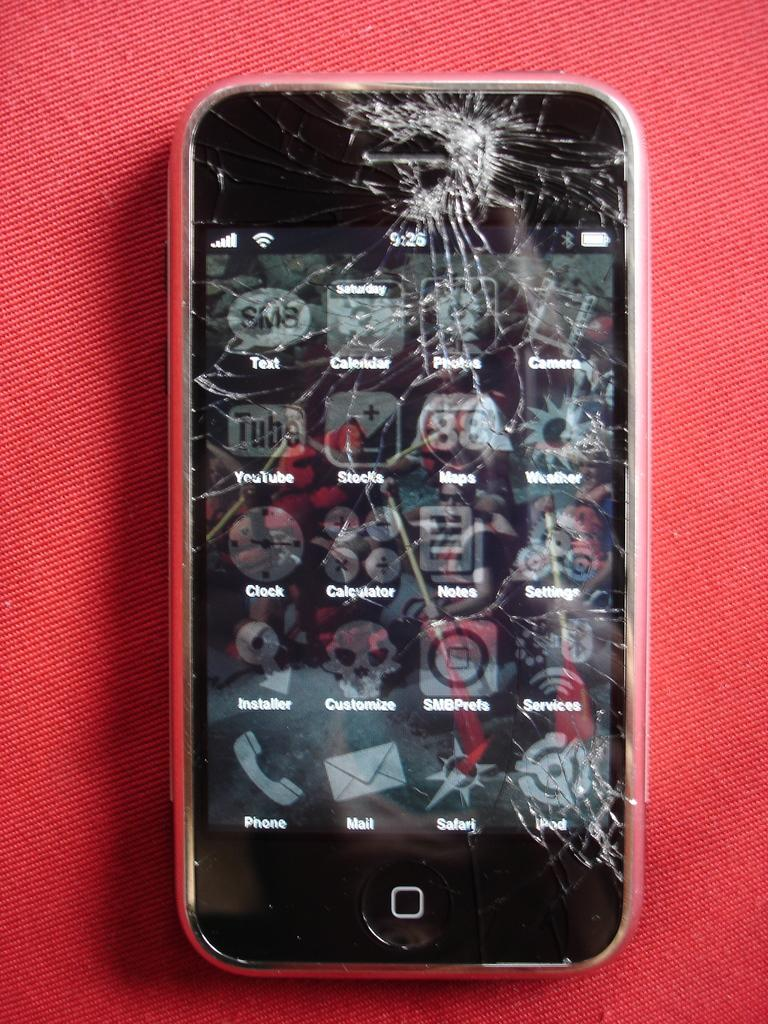Provide a one-sentence caption for the provided image. Cracked iphone that shows the home screen and a full battery. 